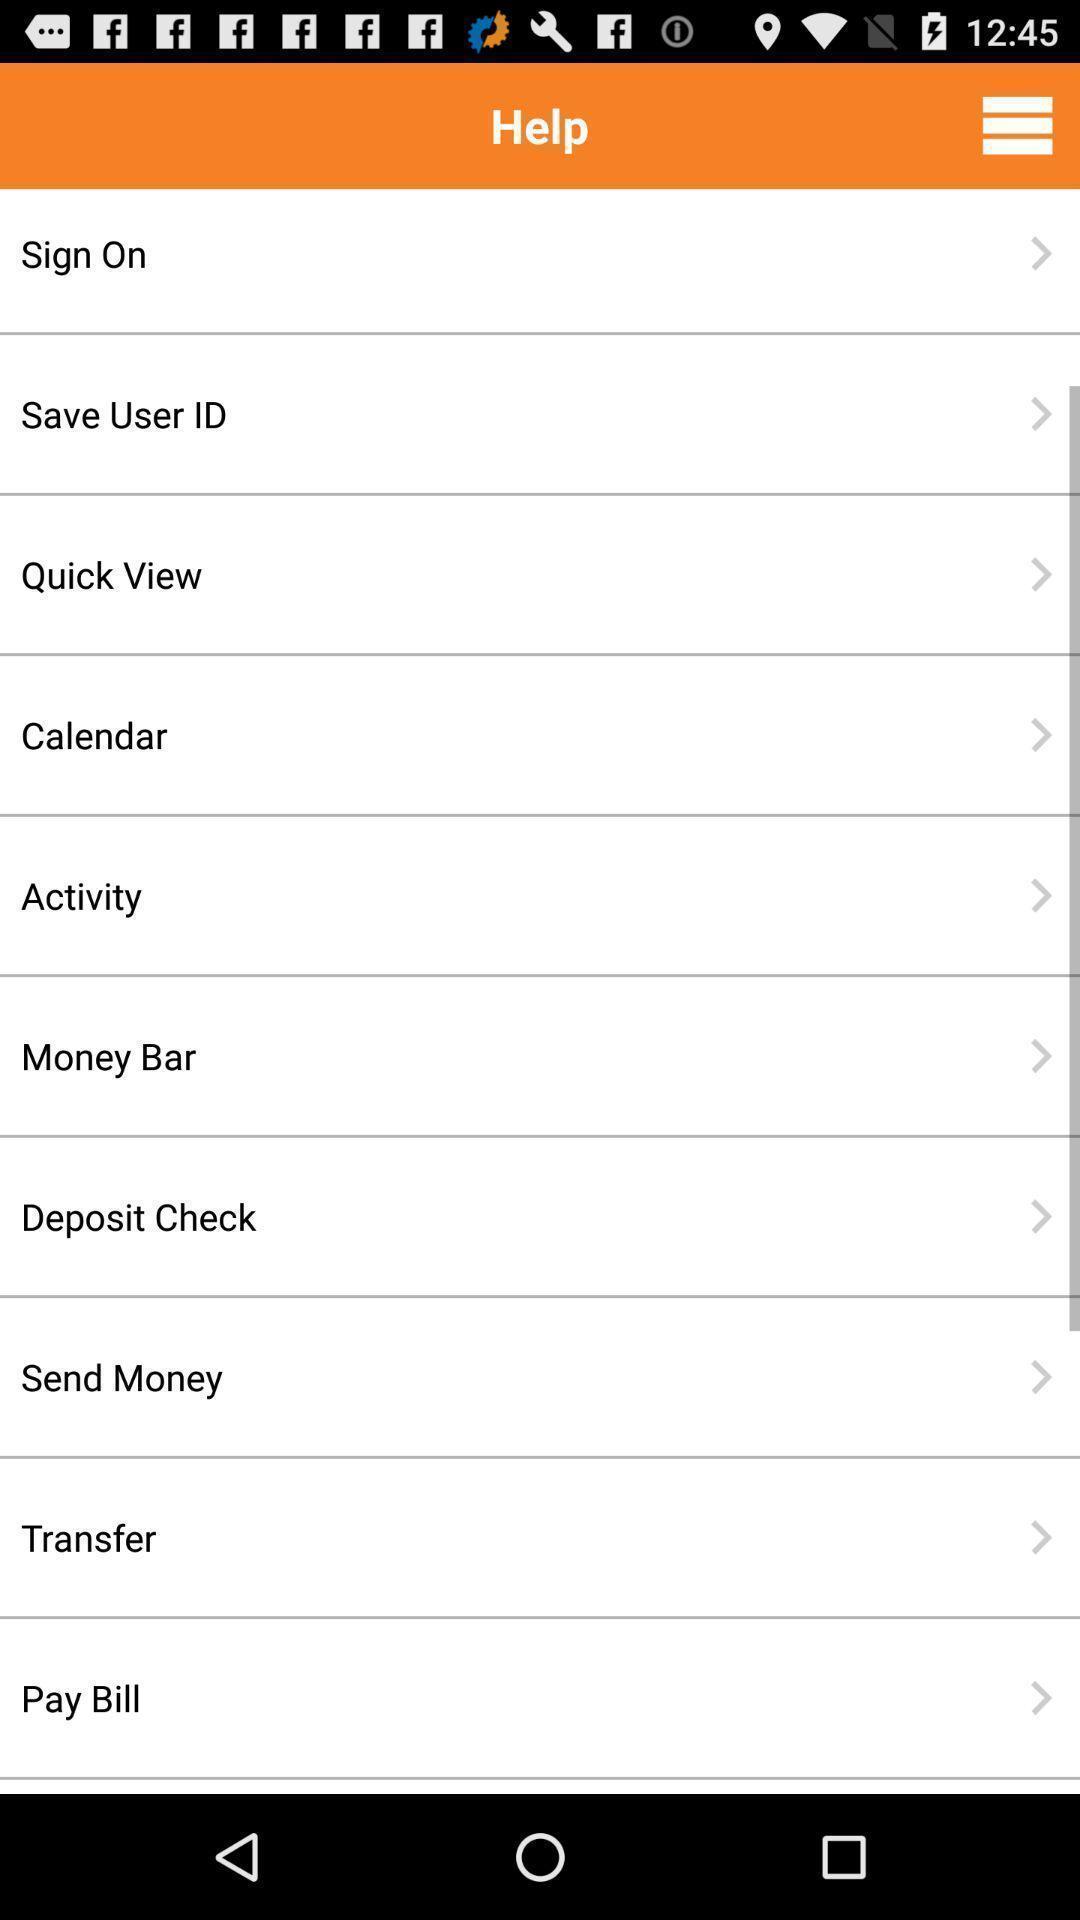Summarize the information in this screenshot. Page showing different options. 